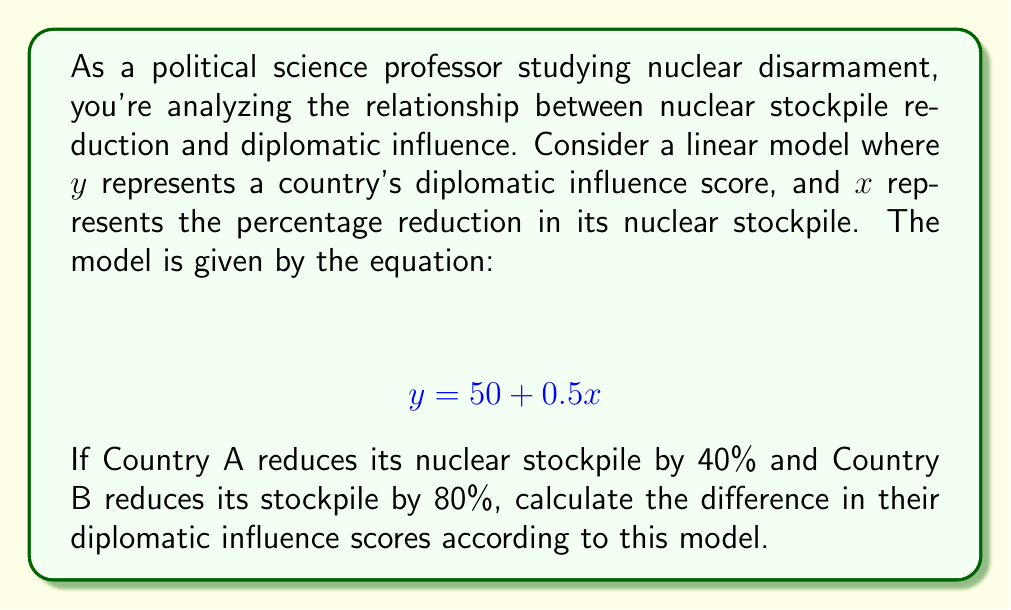Give your solution to this math problem. To solve this problem, we'll follow these steps:

1. Understand the given linear model:
   $$ y = 50 + 0.5x $$
   Where $y$ is the diplomatic influence score and $x$ is the percentage reduction in nuclear stockpile.

2. Calculate the diplomatic influence score for Country A:
   - Country A reduces its stockpile by 40%, so $x_A = 40$
   - $y_A = 50 + 0.5(40)$
   - $y_A = 50 + 20 = 70$

3. Calculate the diplomatic influence score for Country B:
   - Country B reduces its stockpile by 80%, so $x_B = 80$
   - $y_B = 50 + 0.5(80)$
   - $y_B = 50 + 40 = 90$

4. Calculate the difference in diplomatic influence scores:
   - Difference = $y_B - y_A$
   - Difference = $90 - 70 = 20$

This result suggests that, according to the model, Country B's greater reduction in nuclear stockpile leads to a higher diplomatic influence score compared to Country A.
Answer: The difference in diplomatic influence scores between Country B and Country A is 20 points. 